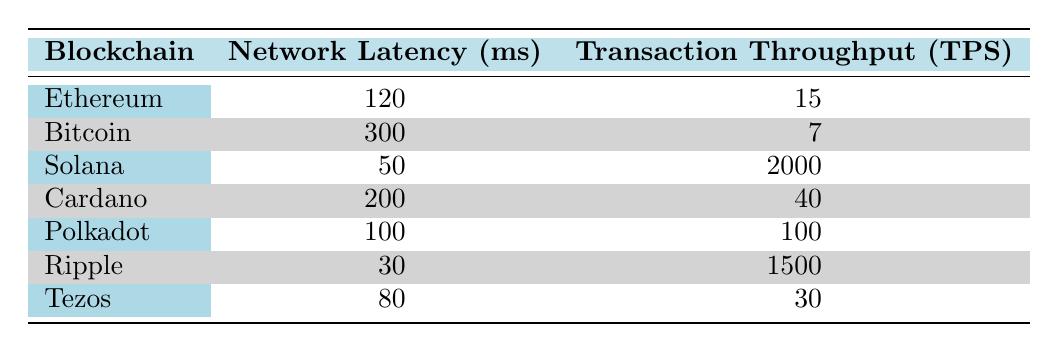What is the network latency for Ethereum? The table lists Ethereum's network latency as 120 milliseconds. This value is directly retrieved from the corresponding row under the "Network Latency (ms)" column.
Answer: 120 ms What is the transaction throughput for Ripple? According to the table, Ripple has a transaction throughput of 1500 transactions per second (TPS). This is obtained from the specific row that lists Ripple under the "Transaction Throughput (TPS)" column.
Answer: 1500 TPS Which blockchain has the lowest network latency and what is that value? The table shows Ripple with the lowest network latency at 30 milliseconds. By comparing all the values in the "Network Latency (ms)" column, it is clear that Ripple's latency is the minimum.
Answer: Ripple, 30 ms What is the average transaction throughput for all blockchain systems listed? By summing the transaction throughputs: 15 + 7 + 2000 + 40 + 100 + 1500 + 30 = 2692. There are 7 blockchain systems, so the average is 2692/7 = 384.57.
Answer: 384.57 TPS Is the transaction throughput for Solana greater than 100 TPS? The table indicates that Solana has a transaction throughput of 2000 TPS. Since 2000 TPS is greater than 100 TPS, the answer is yes.
Answer: Yes Which blockchain has the highest transaction throughput? The throughput for Solana is listed as 2000 TPS, which is higher than any other blockchain in the table. Comparison of the "Transaction Throughput (TPS)" values confirms this as the maximum.
Answer: Solana What is the difference in network latency between Bitcoin and Cardano? Bitcoin's latency is 300 ms and Cardano's is 200 ms. The difference is calculated as 300 - 200 = 100 ms. This subtraction finds the gap between both values in the "Network Latency (ms)" column.
Answer: 100 ms Are there any blockchains with more than 100 TPS? The table shows both Solana with 2000 TPS and Ripple with 1500 TPS, both greater than 100 TPS. Confirming these entries indicates that there are blockchains fulfilling this criterion.
Answer: Yes Which blockchain has a higher transaction throughput, Ethereum or Cardano? The table lists Ethereum with 15 TPS and Cardano with 40 TPS. Comparing these values shows that Cardano has a higher transaction throughput than Ethereum.
Answer: Cardano 